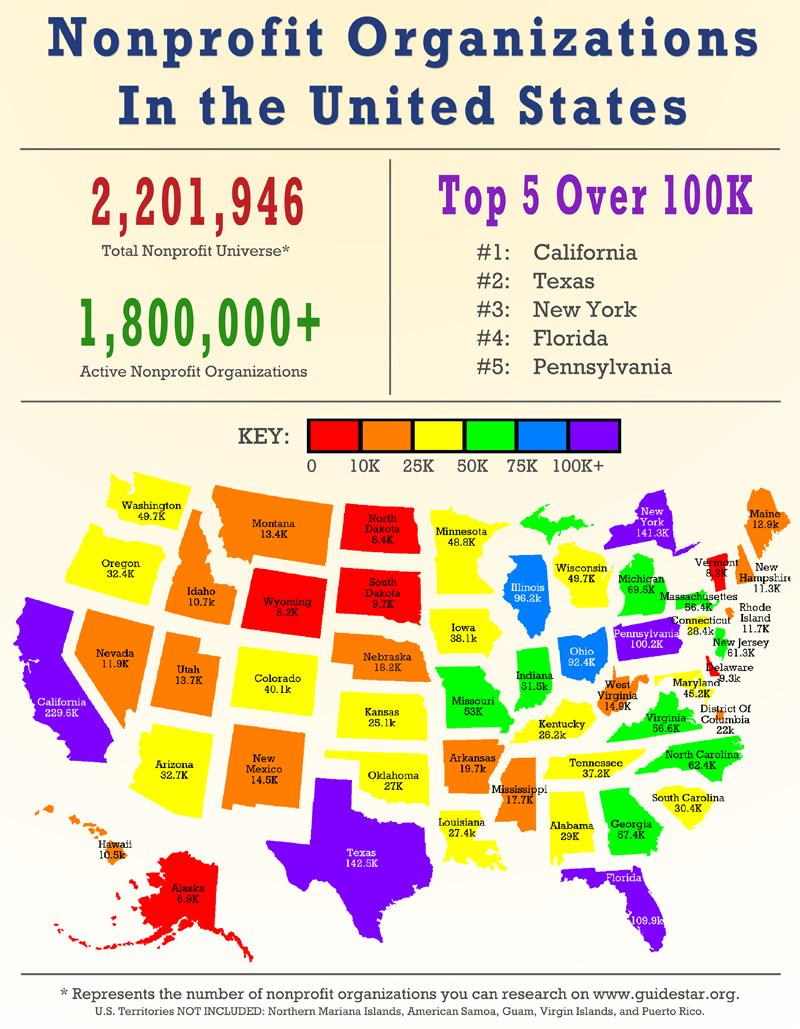Highlight a few significant elements in this photo. There are over 1.8 million active nonprofit organizations currently available in the United States. 